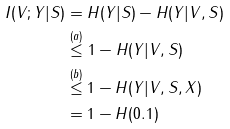<formula> <loc_0><loc_0><loc_500><loc_500>I ( V ; Y | S ) & = H ( Y | S ) - H ( Y | V , S ) \\ & \stackrel { ( a ) } { \leq } 1 - H ( Y | V , S ) \\ & \stackrel { ( b ) } { \leq } 1 - H ( Y | V , S , X ) \\ & = 1 - H ( 0 . 1 )</formula> 